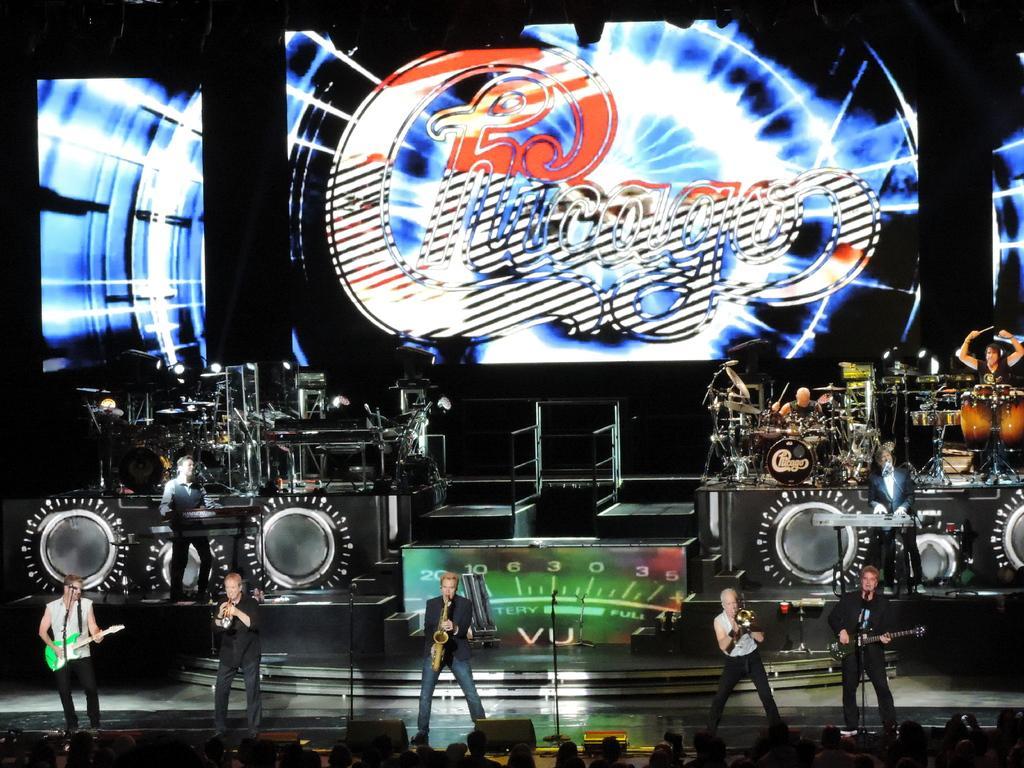Can you describe this image briefly? In this image I can see five person standing and playing the musical instruments. There is a mic and stand. On the stage there are musical instruments. There are drums. At the back side there is a screen and some is written on it. 